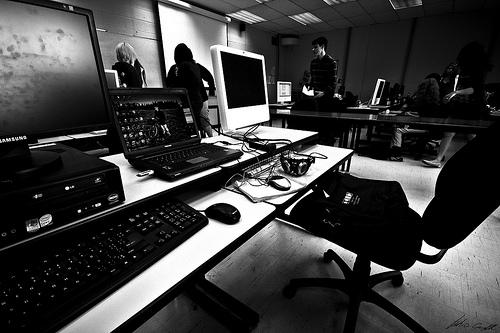Provide a list of objects in the image that might typically be found in an office setting. Desk chairs, a computer mouse, a computer keyboard, a computer monitor, a laptop, a computer tower, wires and cables, and a headset. Analyze any potential interaction between a computer mouse and a computer keyboard in the image. The computer mouse and keyboard are in close proximity on the table, which suggests that they could be used together as part of a desktop computer setup. Based on the objects and people in the image, what kind of task might they be performing or working on? The people and objects in the image suggest that they might be working on some computer-related tasks, such as programming, data entry, or office work. Estimate the size and appearance of the black rolling office chair in the image. The black rolling office chair appears to be medium-sized, approximately 212 pixels in width and height. What are the different types of computer equipment visible in the image? There are a computer mouse, a black keyboard, a white computer monitor, wires and cables, a computer tower, a laptop, and a white iMac computer. Count the number of times the black computer keyboard is visible in the image. The black computer keyboard is visible 5 times in the image. In the image, identify any office furniture and describe their appearance. There are two desk chairs, one with wheels and another one without wheels, and a table where the computer equipment is placed. Is there any object that may indicate some form of communication in the image? There is a wired head set in the image, which may be used for communication purposes. Describe any people present in the image and what they are doing. There is a man standing by a table and a woman with blonde hair, both appear to be interacting or working with the computer equipment. 